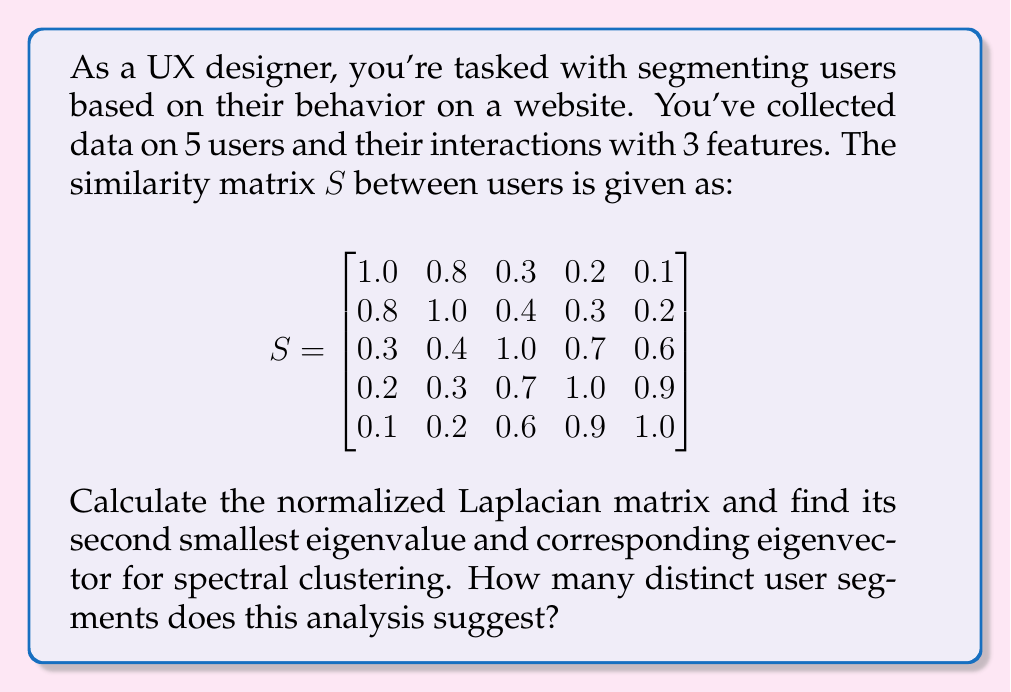Solve this math problem. 1) First, we need to calculate the degree matrix $D$. The degree of each node is the sum of its similarities:

   $$D = \text{diag}(2.4, 2.7, 3.0, 3.1, 2.8)$$

2) Now we can calculate the normalized Laplacian matrix $L_{\text{sym}}$:

   $$L_{\text{sym}} = I - D^{-1/2}SD^{-1/2}$$

   Where $I$ is the identity matrix. Calculating this:

   $$L_{\text{sym}} = \begin{bmatrix}
   0.5833 & -0.3162 & -0.1125 & -0.0739 & -0.0388 \\
   -0.3162 & 0.5185 & -0.1491 & -0.1102 & -0.0775 \\
   -0.1125 & -0.1491 & 0.5667 & -0.2437 & -0.2182 \\
   -0.0739 & -0.1102 & -0.2437 & 0.5484 & -0.3251 \\
   -0.0388 & -0.0775 & -0.2182 & -0.3251 & 0.5714
   \end{bmatrix}$$

3) We need to find the eigenvalues and eigenvectors of $L_{\text{sym}}$. The second smallest eigenvalue and its corresponding eigenvector are of interest for spectral clustering.

4) Calculating the eigenvalues and sorting them in ascending order:

   $$\lambda_1 = 0, \lambda_2 = 0.2322, \lambda_3 = 0.4590, \lambda_4 = 0.7657, \lambda_5 = 1.5431$$

5) The second smallest eigenvalue is $\lambda_2 = 0.2322$. The corresponding eigenvector is:

   $$v_2 = [-0.5237, -0.4470, 0.1744, 0.4935, 0.5028]^T$$

6) To determine the number of clusters, we look at the sign of the components in $v_2$. There's a clear division between negative and positive values, suggesting two distinct clusters.

7) The first two users (negative values) form one cluster, while the last three users (positive values) form another cluster.
Answer: 2 user segments 